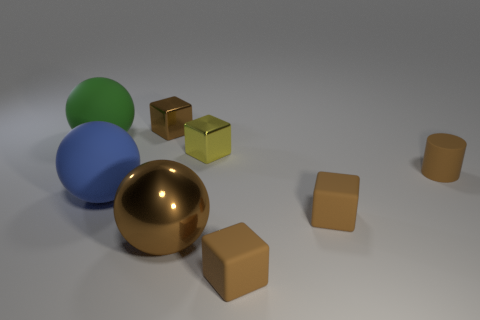How many brown cubes must be subtracted to get 1 brown cubes? 2 Subtract all green spheres. How many spheres are left? 2 Subtract all cylinders. How many objects are left? 7 Add 1 big blue rubber cubes. How many objects exist? 9 Subtract 0 gray spheres. How many objects are left? 8 Subtract 1 cylinders. How many cylinders are left? 0 Subtract all purple spheres. Subtract all gray cubes. How many spheres are left? 3 Subtract all brown blocks. How many green spheres are left? 1 Subtract all red matte things. Subtract all rubber spheres. How many objects are left? 6 Add 7 big brown things. How many big brown things are left? 8 